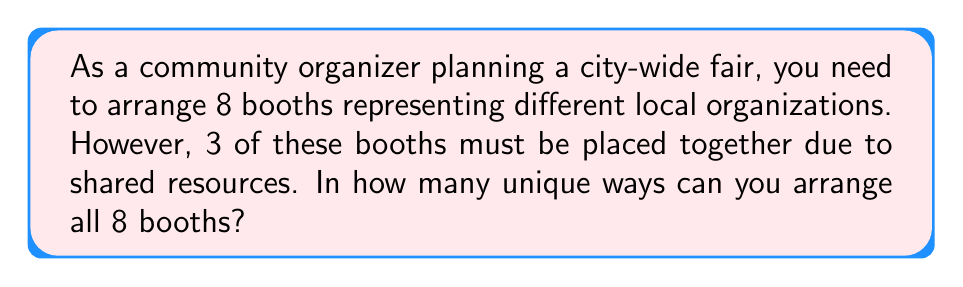Give your solution to this math problem. Let's approach this problem step-by-step:

1) First, consider the 3 booths that must be placed together as one unit. This means we effectively have 6 units to arrange: the group of 3 booths and the other 5 individual booths.

2) The number of ways to arrange 6 distinct units is simply 6!, which is:

   $$6! = 6 \times 5 \times 4 \times 3 \times 2 \times 1 = 720$$

3) However, we're not done yet. Remember that the group of 3 booths can also be arranged among themselves. The number of ways to arrange 3 booths is 3!:

   $$3! = 3 \times 2 \times 1 = 6$$

4) According to the multiplication principle, if we have 720 ways to arrange the 6 units, and for each of these arrangements, we have 6 ways to arrange the 3 booths within their group, the total number of arrangements is:

   $$720 \times 6 = 4,320$$

Therefore, there are 4,320 unique ways to arrange the 8 booths under these conditions.
Answer: 4,320 